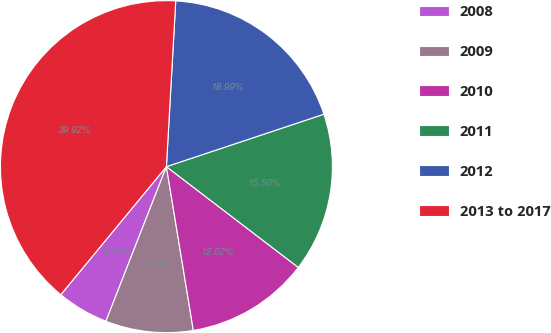Convert chart. <chart><loc_0><loc_0><loc_500><loc_500><pie_chart><fcel>2008<fcel>2009<fcel>2010<fcel>2011<fcel>2012<fcel>2013 to 2017<nl><fcel>5.04%<fcel>8.53%<fcel>12.02%<fcel>15.5%<fcel>18.99%<fcel>39.92%<nl></chart> 